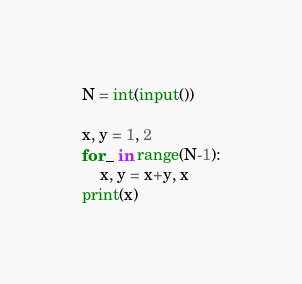Convert code to text. <code><loc_0><loc_0><loc_500><loc_500><_Python_>N = int(input())

x, y = 1, 2
for _ in range(N-1):
    x, y = x+y, x
print(x)
</code> 